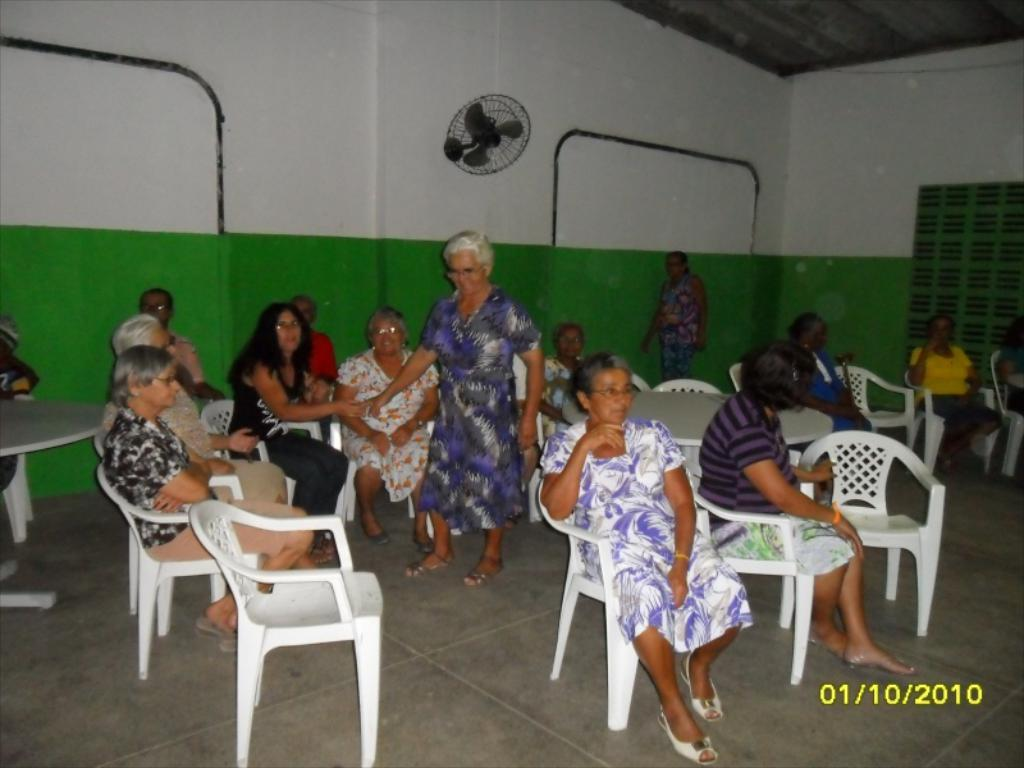What are the women in the image doing? There are women sitting on the hair in the image. Are there any women standing in the image? Yes, two women are standing in the image. What can be seen on the wall in the image? There is a table fan on the wall in the image. Is there any source of natural light in the image? Yes, there is a window in the image. What type of iron is being used by the women in the image? There is no iron present in the image; the women are sitting on the hair. Can you tell me how many cameras are visible in the image? There are no cameras visible in the image. 